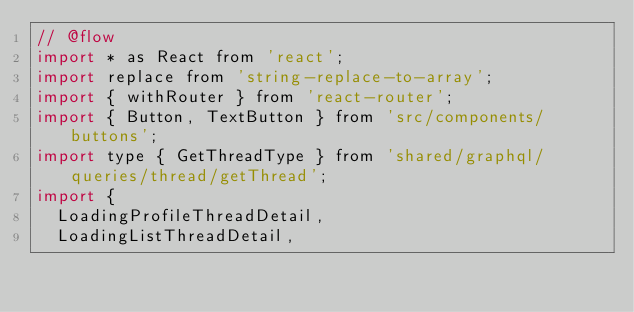Convert code to text. <code><loc_0><loc_0><loc_500><loc_500><_JavaScript_>// @flow
import * as React from 'react';
import replace from 'string-replace-to-array';
import { withRouter } from 'react-router';
import { Button, TextButton } from 'src/components/buttons';
import type { GetThreadType } from 'shared/graphql/queries/thread/getThread';
import {
  LoadingProfileThreadDetail,
  LoadingListThreadDetail,</code> 